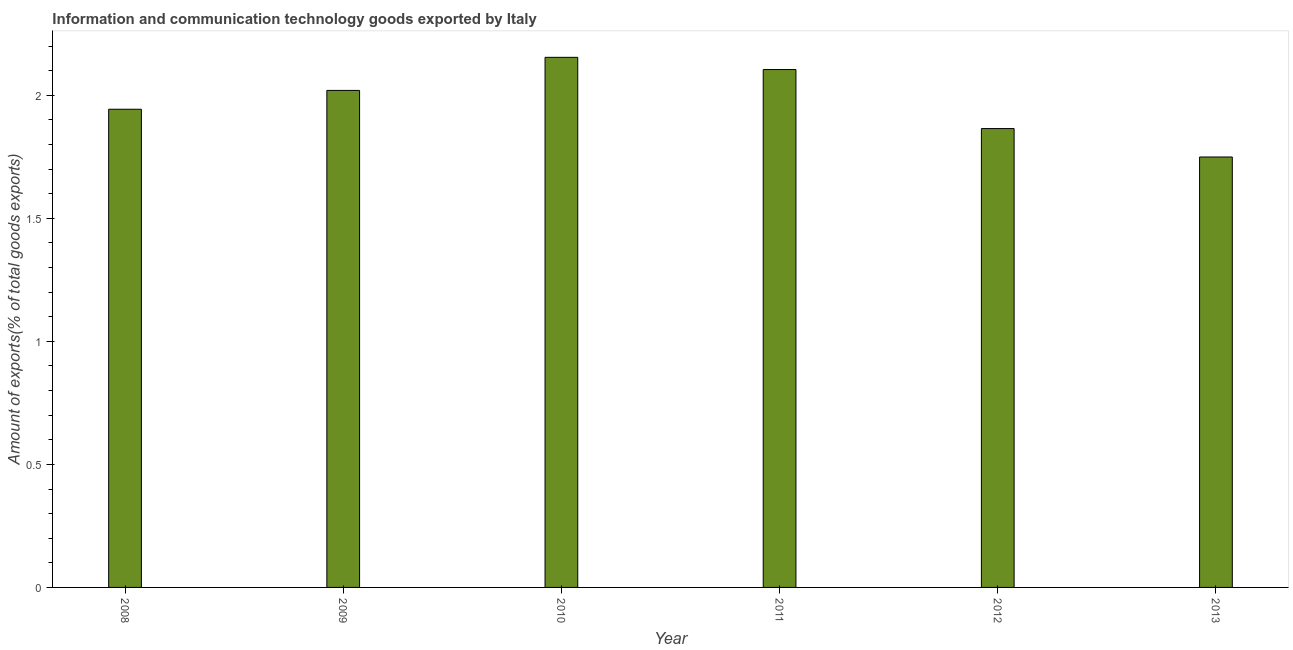Does the graph contain any zero values?
Offer a very short reply. No. What is the title of the graph?
Ensure brevity in your answer.  Information and communication technology goods exported by Italy. What is the label or title of the X-axis?
Provide a succinct answer. Year. What is the label or title of the Y-axis?
Offer a very short reply. Amount of exports(% of total goods exports). What is the amount of ict goods exports in 2010?
Your answer should be very brief. 2.15. Across all years, what is the maximum amount of ict goods exports?
Provide a succinct answer. 2.15. Across all years, what is the minimum amount of ict goods exports?
Ensure brevity in your answer.  1.75. In which year was the amount of ict goods exports minimum?
Make the answer very short. 2013. What is the sum of the amount of ict goods exports?
Your answer should be compact. 11.84. What is the difference between the amount of ict goods exports in 2008 and 2013?
Your response must be concise. 0.19. What is the average amount of ict goods exports per year?
Keep it short and to the point. 1.97. What is the median amount of ict goods exports?
Your response must be concise. 1.98. In how many years, is the amount of ict goods exports greater than 1.7 %?
Offer a very short reply. 6. Do a majority of the years between 2008 and 2012 (inclusive) have amount of ict goods exports greater than 1.4 %?
Keep it short and to the point. Yes. What is the ratio of the amount of ict goods exports in 2008 to that in 2013?
Provide a short and direct response. 1.11. Is the amount of ict goods exports in 2012 less than that in 2013?
Your answer should be compact. No. Is the sum of the amount of ict goods exports in 2008 and 2013 greater than the maximum amount of ict goods exports across all years?
Provide a short and direct response. Yes. What is the difference between the highest and the lowest amount of ict goods exports?
Ensure brevity in your answer.  0.41. How many bars are there?
Make the answer very short. 6. Are all the bars in the graph horizontal?
Your answer should be compact. No. How many years are there in the graph?
Provide a short and direct response. 6. What is the difference between two consecutive major ticks on the Y-axis?
Your answer should be very brief. 0.5. What is the Amount of exports(% of total goods exports) in 2008?
Make the answer very short. 1.94. What is the Amount of exports(% of total goods exports) in 2009?
Provide a succinct answer. 2.02. What is the Amount of exports(% of total goods exports) of 2010?
Your answer should be compact. 2.15. What is the Amount of exports(% of total goods exports) of 2011?
Your response must be concise. 2.1. What is the Amount of exports(% of total goods exports) of 2012?
Your answer should be very brief. 1.86. What is the Amount of exports(% of total goods exports) of 2013?
Provide a short and direct response. 1.75. What is the difference between the Amount of exports(% of total goods exports) in 2008 and 2009?
Your answer should be compact. -0.08. What is the difference between the Amount of exports(% of total goods exports) in 2008 and 2010?
Offer a terse response. -0.21. What is the difference between the Amount of exports(% of total goods exports) in 2008 and 2011?
Your answer should be compact. -0.16. What is the difference between the Amount of exports(% of total goods exports) in 2008 and 2012?
Ensure brevity in your answer.  0.08. What is the difference between the Amount of exports(% of total goods exports) in 2008 and 2013?
Give a very brief answer. 0.19. What is the difference between the Amount of exports(% of total goods exports) in 2009 and 2010?
Provide a succinct answer. -0.13. What is the difference between the Amount of exports(% of total goods exports) in 2009 and 2011?
Give a very brief answer. -0.08. What is the difference between the Amount of exports(% of total goods exports) in 2009 and 2012?
Your answer should be compact. 0.16. What is the difference between the Amount of exports(% of total goods exports) in 2009 and 2013?
Your response must be concise. 0.27. What is the difference between the Amount of exports(% of total goods exports) in 2010 and 2011?
Provide a succinct answer. 0.05. What is the difference between the Amount of exports(% of total goods exports) in 2010 and 2012?
Provide a short and direct response. 0.29. What is the difference between the Amount of exports(% of total goods exports) in 2010 and 2013?
Ensure brevity in your answer.  0.41. What is the difference between the Amount of exports(% of total goods exports) in 2011 and 2012?
Your answer should be compact. 0.24. What is the difference between the Amount of exports(% of total goods exports) in 2011 and 2013?
Give a very brief answer. 0.36. What is the difference between the Amount of exports(% of total goods exports) in 2012 and 2013?
Make the answer very short. 0.12. What is the ratio of the Amount of exports(% of total goods exports) in 2008 to that in 2010?
Provide a succinct answer. 0.9. What is the ratio of the Amount of exports(% of total goods exports) in 2008 to that in 2011?
Your answer should be very brief. 0.92. What is the ratio of the Amount of exports(% of total goods exports) in 2008 to that in 2012?
Provide a succinct answer. 1.04. What is the ratio of the Amount of exports(% of total goods exports) in 2008 to that in 2013?
Give a very brief answer. 1.11. What is the ratio of the Amount of exports(% of total goods exports) in 2009 to that in 2010?
Give a very brief answer. 0.94. What is the ratio of the Amount of exports(% of total goods exports) in 2009 to that in 2011?
Your answer should be compact. 0.96. What is the ratio of the Amount of exports(% of total goods exports) in 2009 to that in 2012?
Provide a short and direct response. 1.08. What is the ratio of the Amount of exports(% of total goods exports) in 2009 to that in 2013?
Provide a succinct answer. 1.16. What is the ratio of the Amount of exports(% of total goods exports) in 2010 to that in 2011?
Keep it short and to the point. 1.02. What is the ratio of the Amount of exports(% of total goods exports) in 2010 to that in 2012?
Make the answer very short. 1.16. What is the ratio of the Amount of exports(% of total goods exports) in 2010 to that in 2013?
Your answer should be compact. 1.23. What is the ratio of the Amount of exports(% of total goods exports) in 2011 to that in 2012?
Your response must be concise. 1.13. What is the ratio of the Amount of exports(% of total goods exports) in 2011 to that in 2013?
Provide a short and direct response. 1.2. What is the ratio of the Amount of exports(% of total goods exports) in 2012 to that in 2013?
Ensure brevity in your answer.  1.07. 